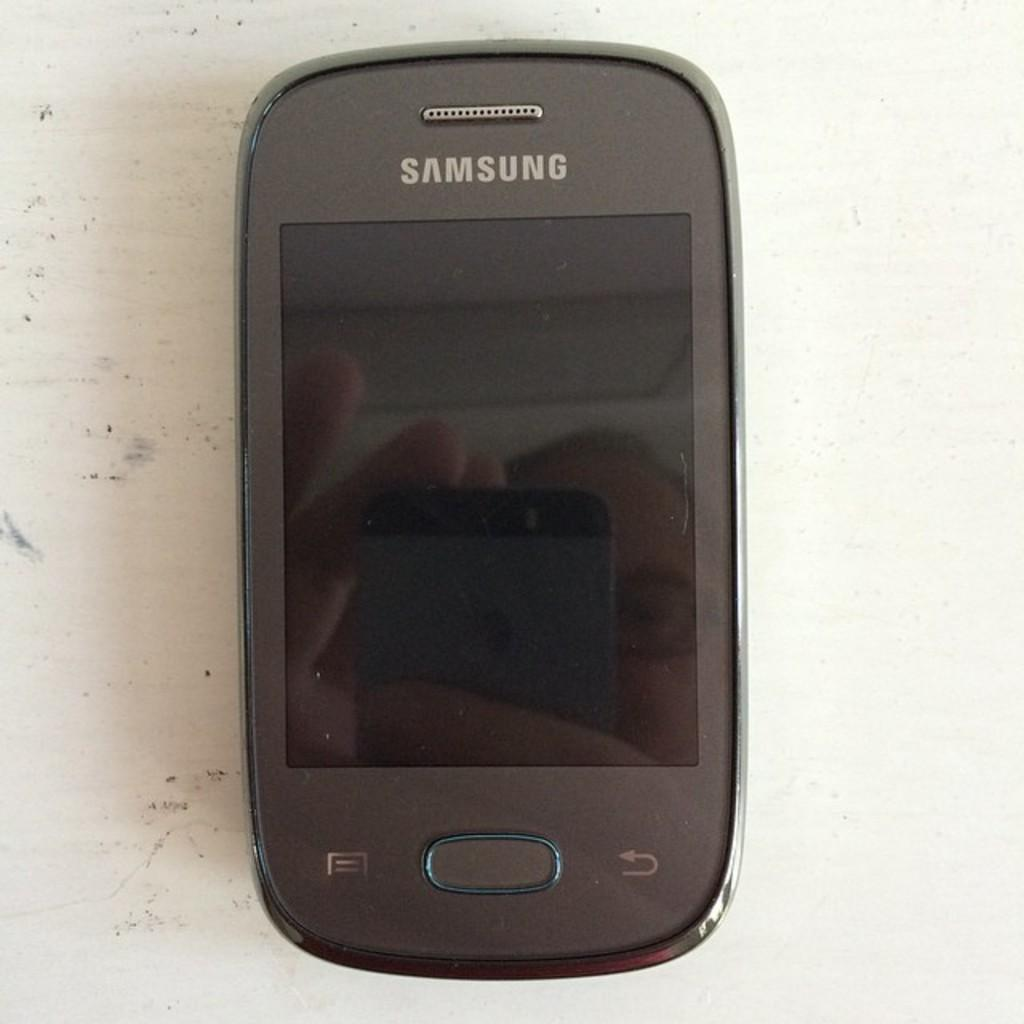<image>
Render a clear and concise summary of the photo. The black cell phone is made by Samsung 